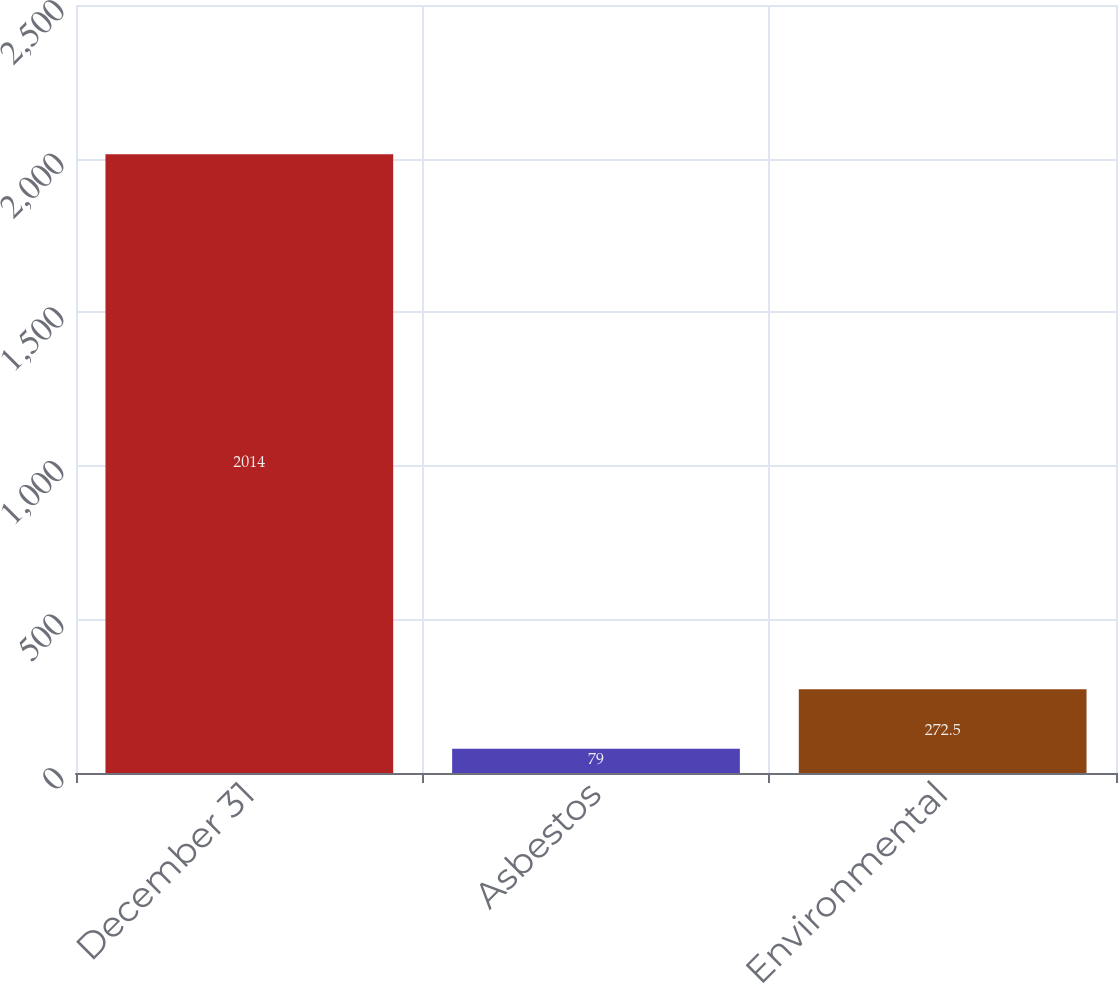Convert chart to OTSL. <chart><loc_0><loc_0><loc_500><loc_500><bar_chart><fcel>December 31<fcel>Asbestos<fcel>Environmental<nl><fcel>2014<fcel>79<fcel>272.5<nl></chart> 